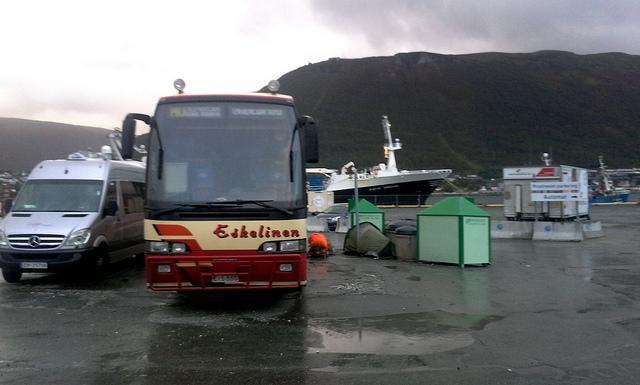How many means of transportation are here?
Give a very brief answer. 3. How many bird are in the photo?
Give a very brief answer. 0. 